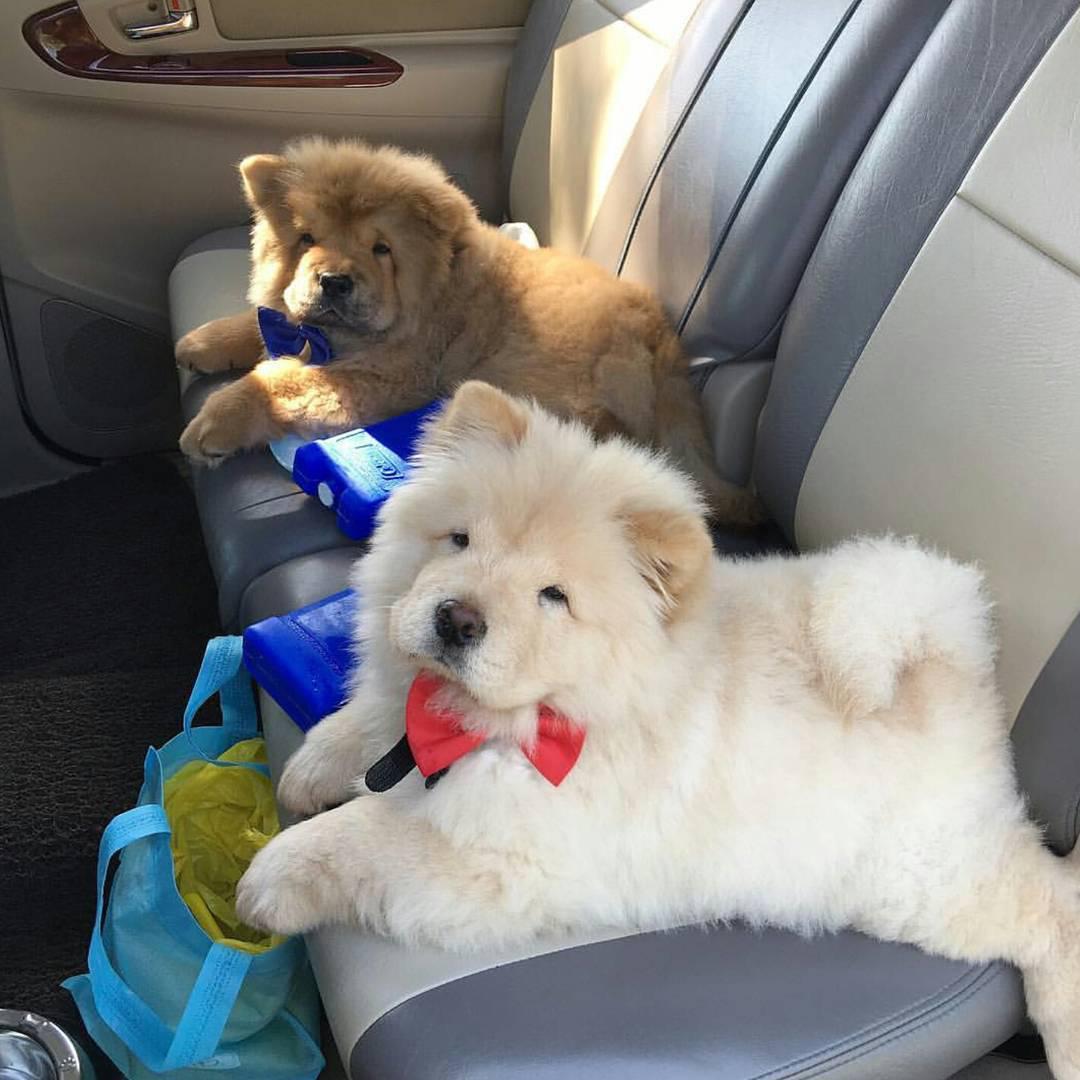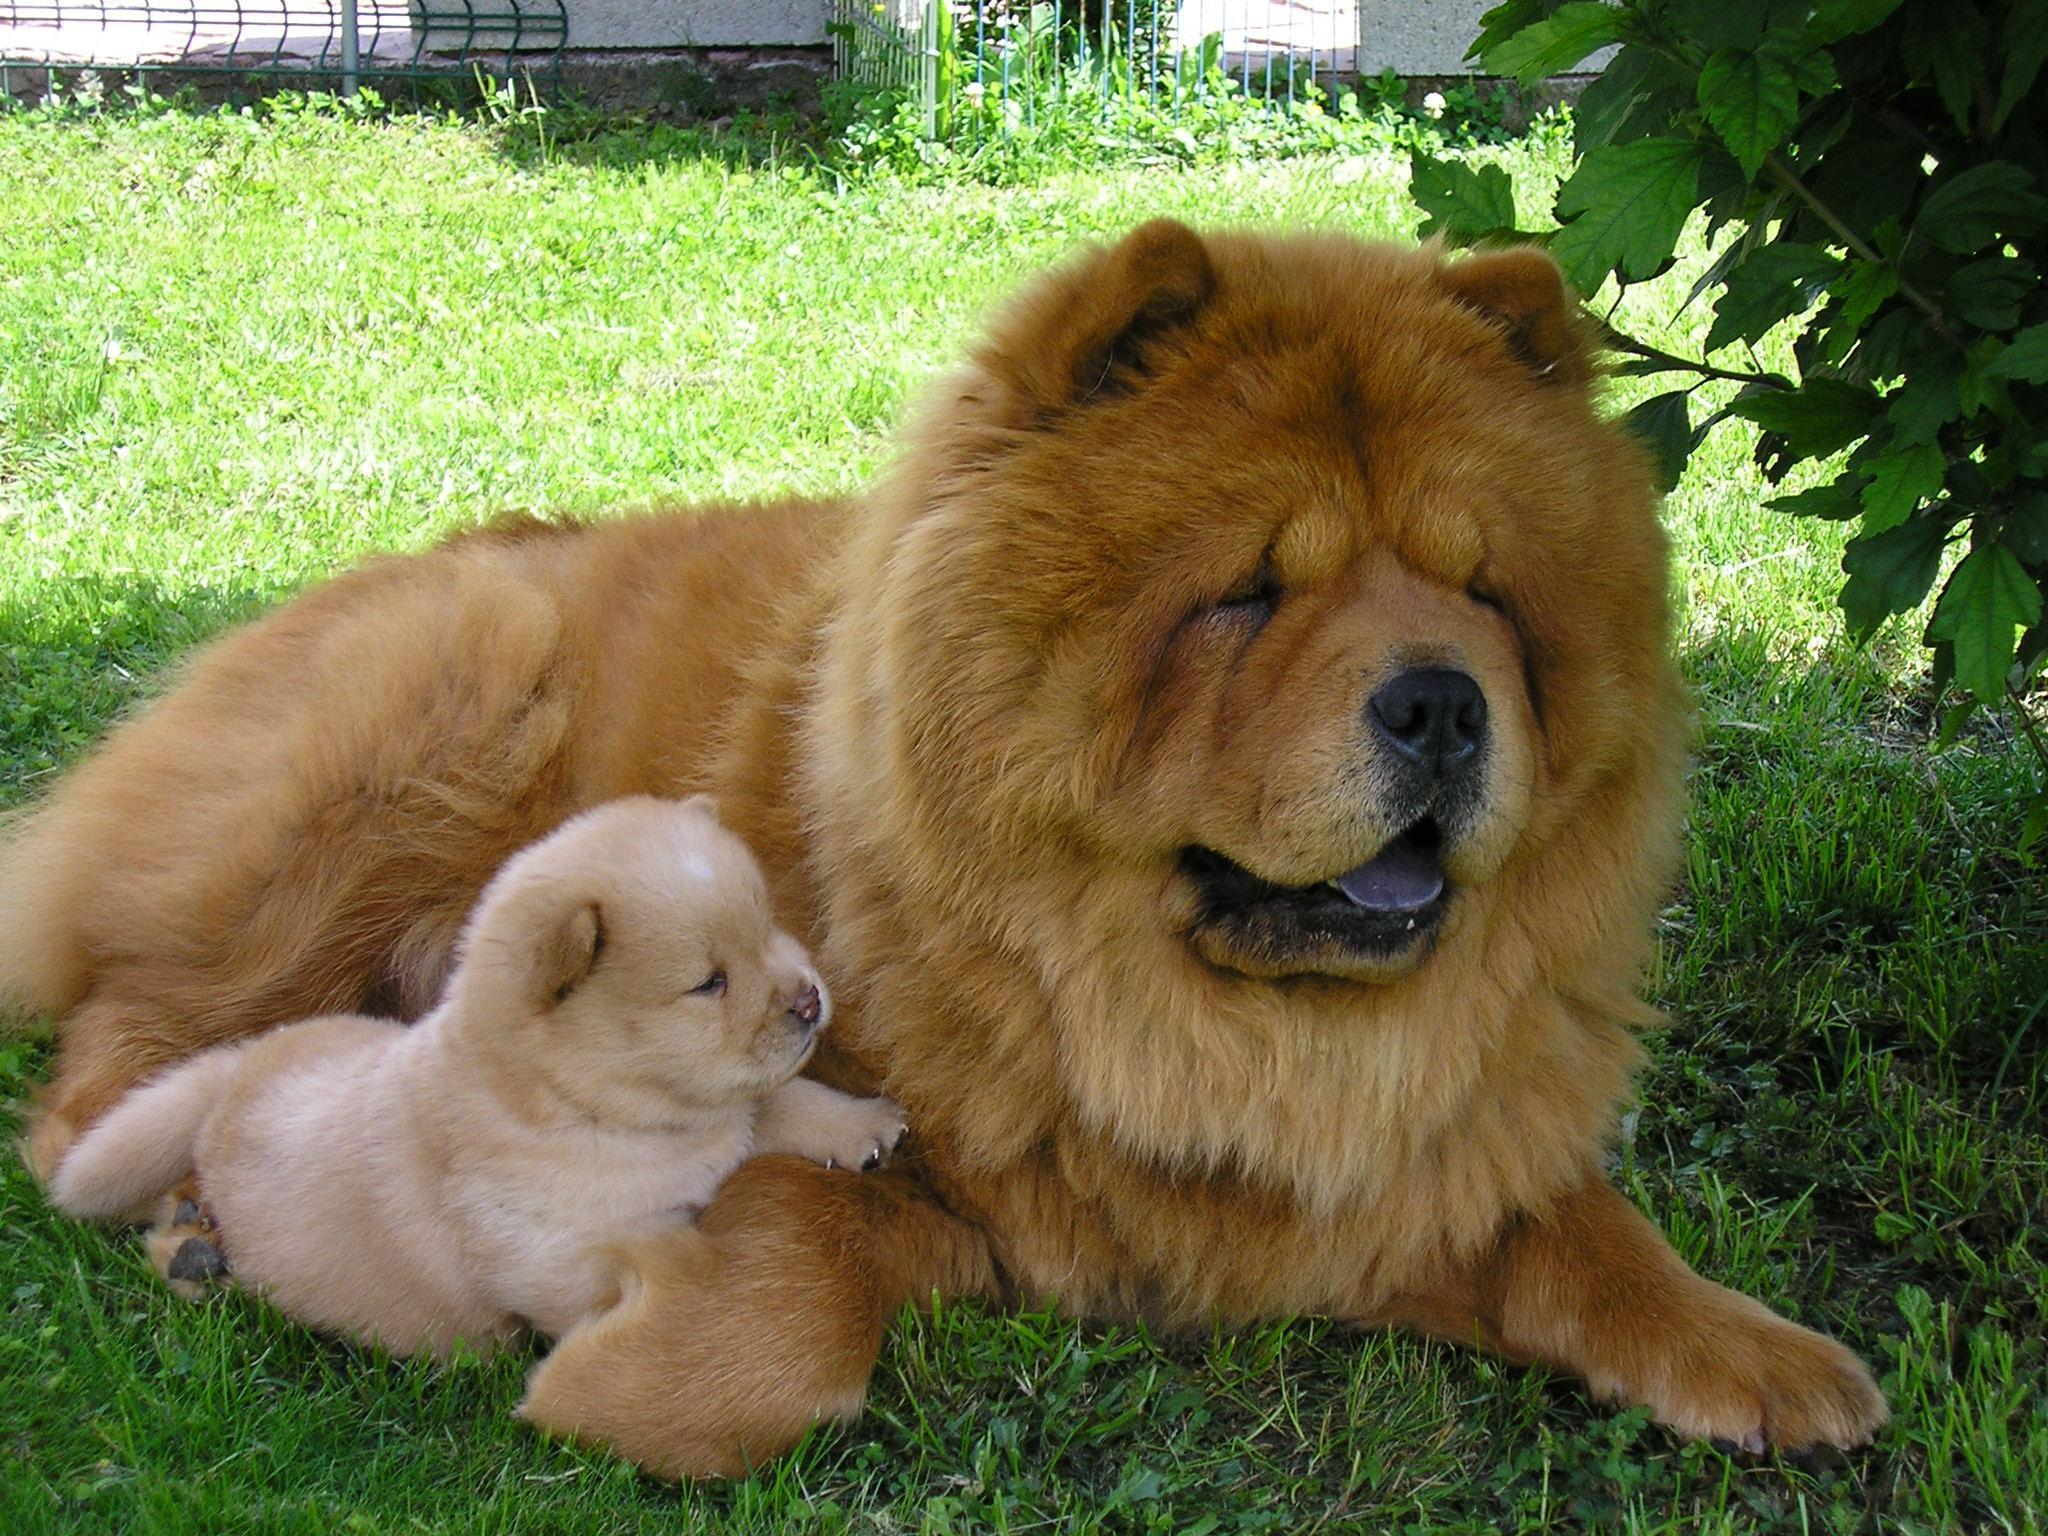The first image is the image on the left, the second image is the image on the right. Analyze the images presented: Is the assertion "There are puppies in each image." valid? Answer yes or no. Yes. The first image is the image on the left, the second image is the image on the right. Examine the images to the left and right. Is the description "There are four dogs in total." accurate? Answer yes or no. Yes. 